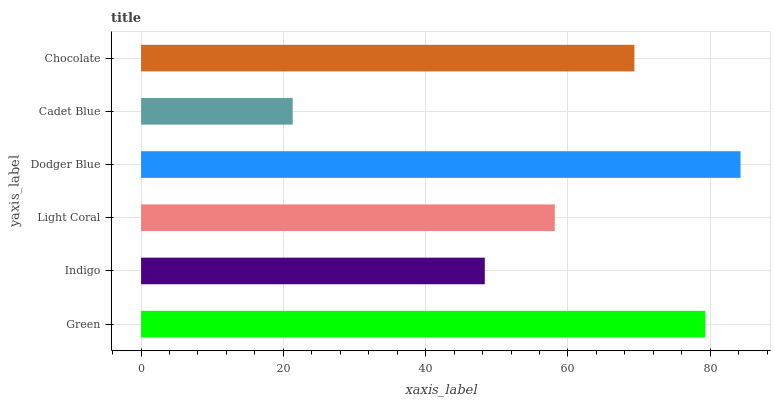Is Cadet Blue the minimum?
Answer yes or no. Yes. Is Dodger Blue the maximum?
Answer yes or no. Yes. Is Indigo the minimum?
Answer yes or no. No. Is Indigo the maximum?
Answer yes or no. No. Is Green greater than Indigo?
Answer yes or no. Yes. Is Indigo less than Green?
Answer yes or no. Yes. Is Indigo greater than Green?
Answer yes or no. No. Is Green less than Indigo?
Answer yes or no. No. Is Chocolate the high median?
Answer yes or no. Yes. Is Light Coral the low median?
Answer yes or no. Yes. Is Dodger Blue the high median?
Answer yes or no. No. Is Indigo the low median?
Answer yes or no. No. 